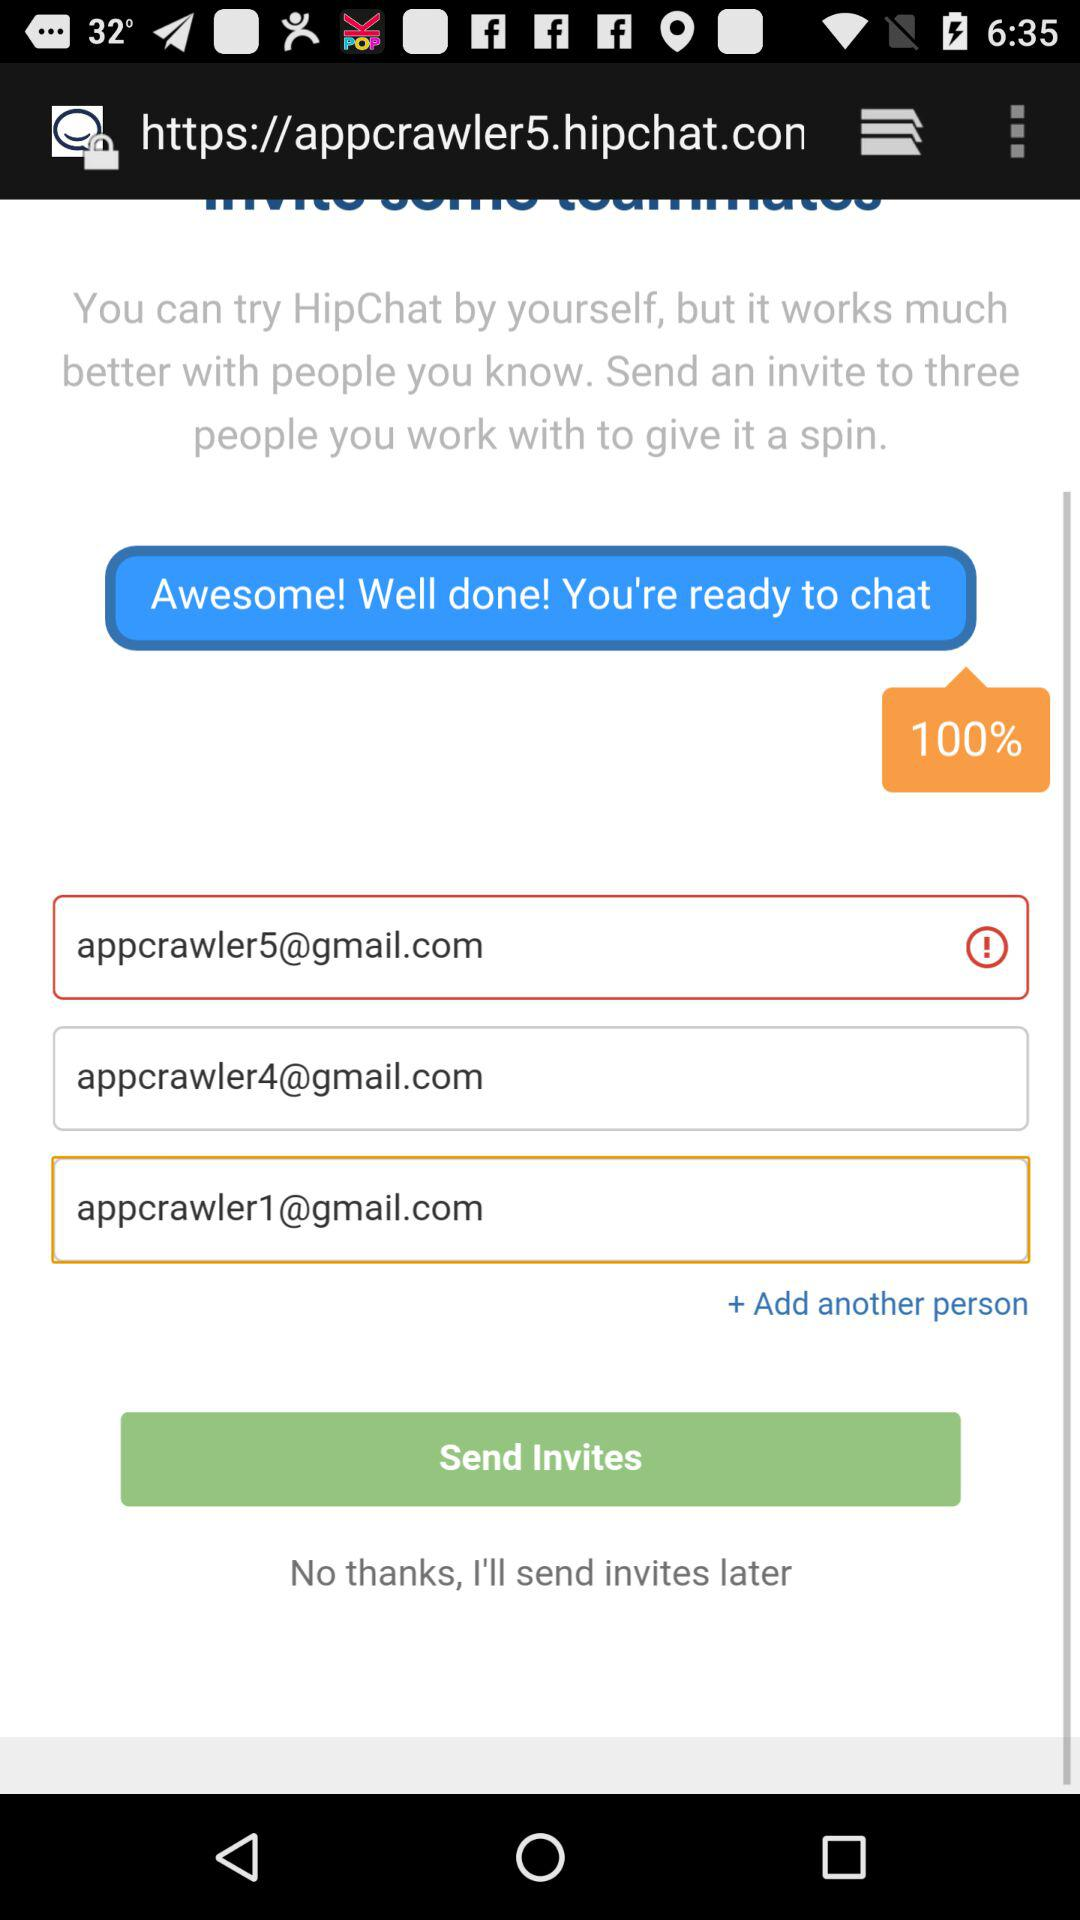How many people should we invite to get a spin? You should invite three people to get a spin. 